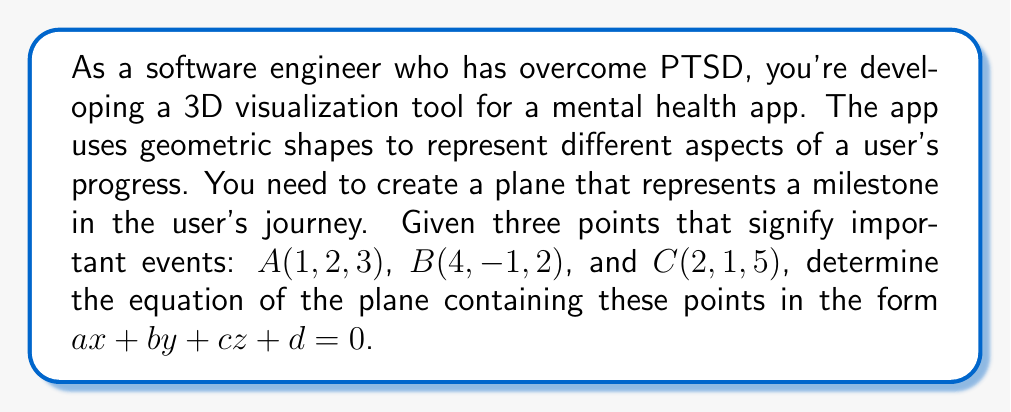Can you solve this math problem? To find the equation of a plane given three points, we can follow these steps:

1. Calculate two vectors on the plane:
   $\vec{AB} = B - A = (4-1, -1-2, 2-3) = (3, -3, -1)$
   $\vec{AC} = C - A = (2-1, 1-2, 5-3) = (1, -1, 2)$

2. Find the normal vector to the plane by calculating the cross product of $\vec{AB}$ and $\vec{AC}$:
   $\vec{n} = \vec{AB} \times \vec{AC} = \begin{vmatrix} 
   i & j & k \\
   3 & -3 & -1 \\
   1 & -1 & 2
   \end{vmatrix}$

   $\vec{n} = ((-3)(2) - (-1)(-1))i - ((3)(2) - (-1)(1))j + ((3)(-1) - (-3)(1))k$
   $\vec{n} = -5i - 7j - 6k$

3. The normal vector gives us the coefficients $a$, $b$, and $c$ in the plane equation:
   $ax + by + cz + d = 0$
   $-5x - 7y - 6z + d = 0$

4. To find $d$, substitute the coordinates of any of the given points (let's use $A(1, 2, 3)$):
   $-5(1) - 7(2) - 6(3) + d = 0$
   $-5 - 14 - 18 + d = 0$
   $d = 37$

5. Therefore, the equation of the plane is:
   $-5x - 7y - 6z + 37 = 0$
Answer: $$-5x - 7y - 6z + 37 = 0$$ 